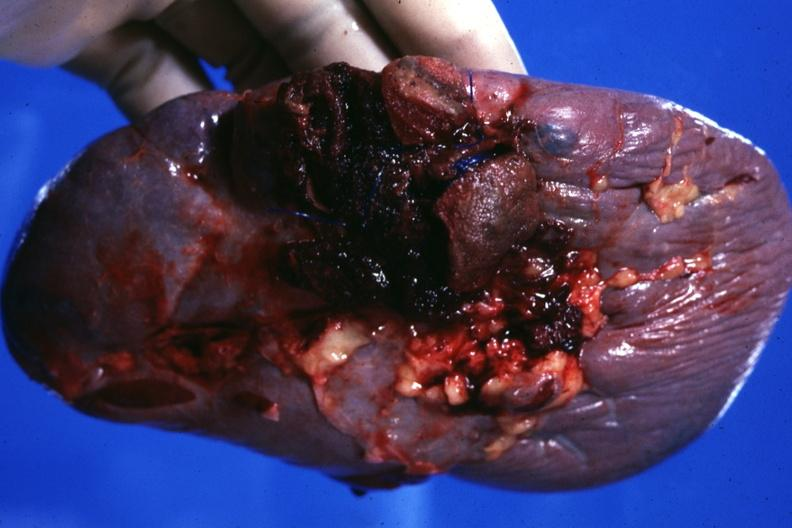s hemorrhagic corpus luteum present?
Answer the question using a single word or phrase. No 